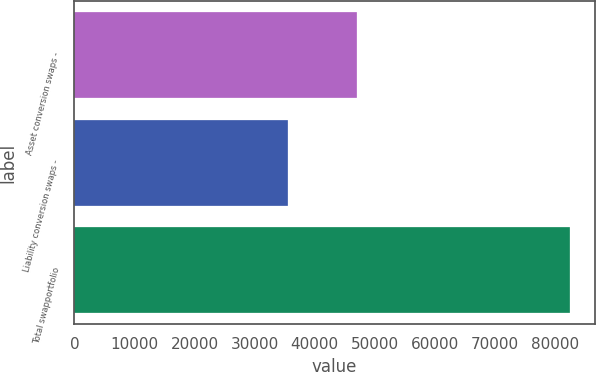Convert chart. <chart><loc_0><loc_0><loc_500><loc_500><bar_chart><fcel>Asset conversion swaps -<fcel>Liability conversion swaps -<fcel>Total swapportfolio<nl><fcel>47044<fcel>35476<fcel>82520<nl></chart> 